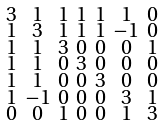<formula> <loc_0><loc_0><loc_500><loc_500>\begin{smallmatrix} 3 & 1 & 1 & 1 & 1 & 1 & 0 \\ 1 & 3 & 1 & 1 & 1 & - 1 & 0 \\ 1 & 1 & 3 & 0 & 0 & 0 & 1 \\ 1 & 1 & 0 & 3 & 0 & 0 & 0 \\ 1 & 1 & 0 & 0 & 3 & 0 & 0 \\ 1 & - 1 & 0 & 0 & 0 & 3 & 1 \\ 0 & 0 & 1 & 0 & 0 & 1 & 3 \end{smallmatrix}</formula> 